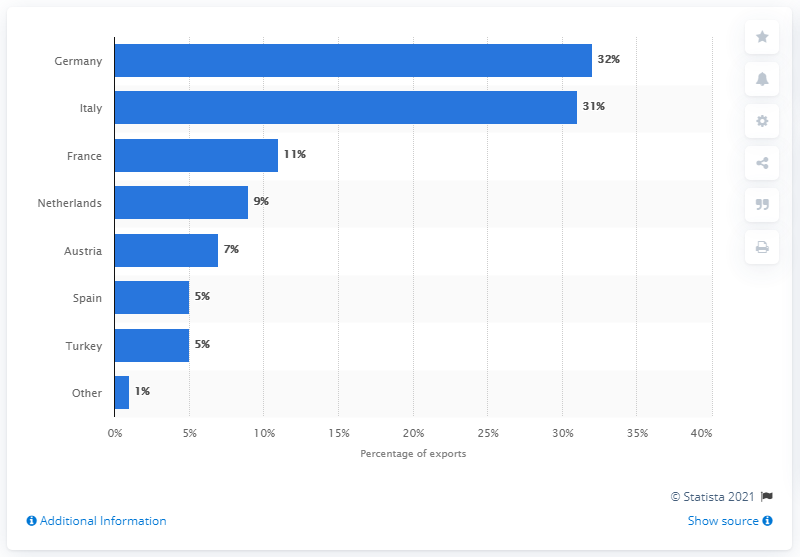Point out several critical features in this image. In 2010, Germany was the country that received the largest share of Syria's oil exports, totaling 32 percent. 